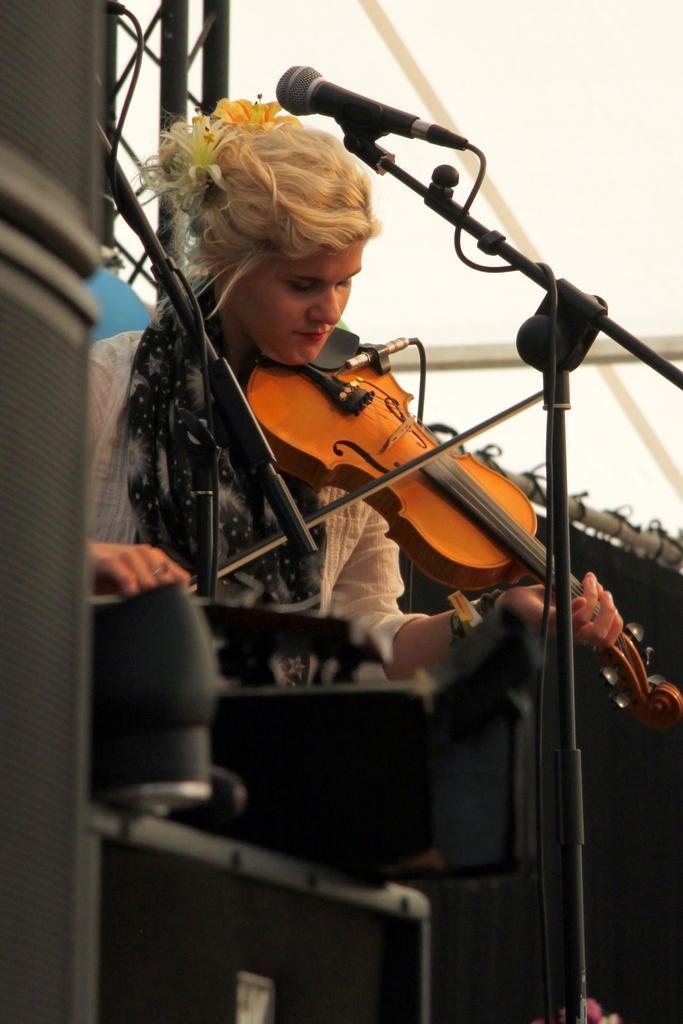Please provide a concise description of this image. In the image we can see there is a woman who are standing and playing violin. 